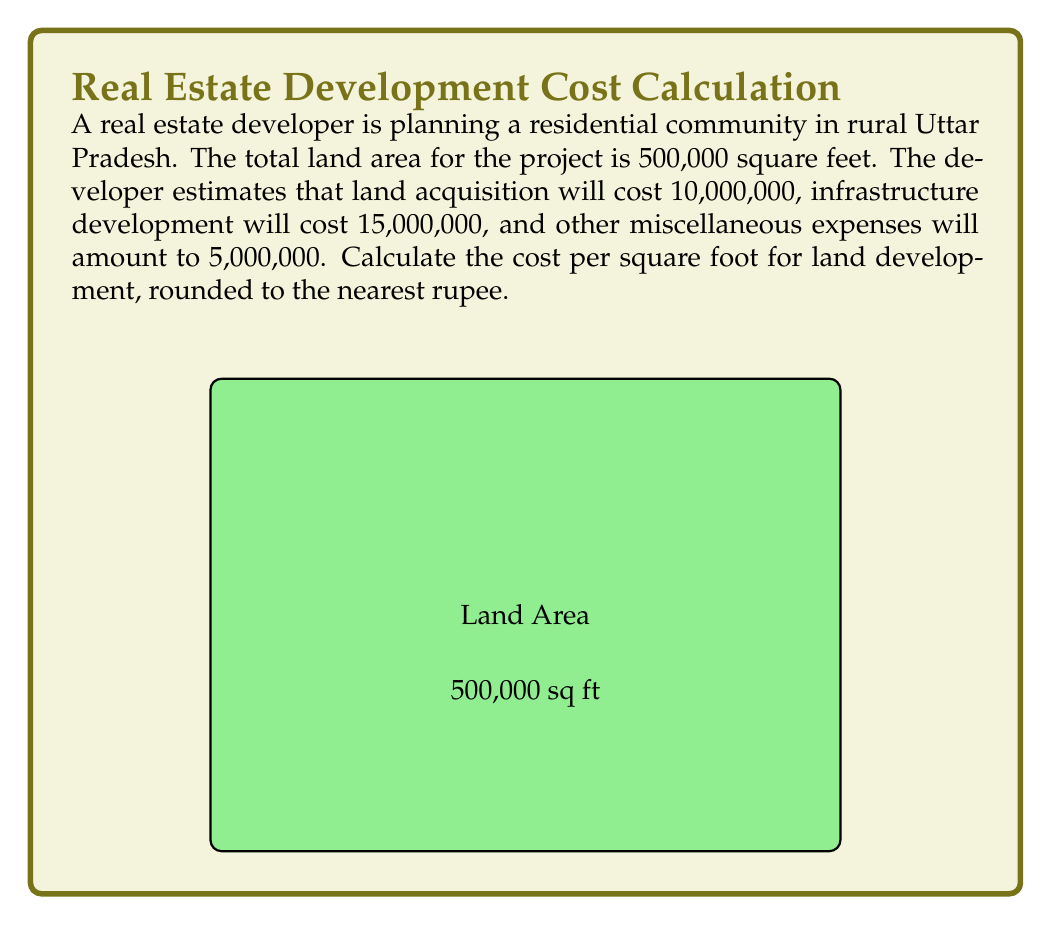Teach me how to tackle this problem. Let's approach this step-by-step:

1) First, we need to calculate the total cost of the project:
   Land acquisition cost: ₹10,000,000
   Infrastructure development cost: ₹15,000,000
   Miscellaneous expenses: ₹5,000,000

   Total cost = ₹10,000,000 + ₹15,000,000 + ₹5,000,000 = ₹30,000,000

2) Now, we have:
   Total cost = ₹30,000,000
   Total area = 500,000 square feet

3) To calculate the cost per square foot, we use the formula:
   $$ \text{Cost per square foot} = \frac{\text{Total cost}}{\text{Total area}} $$

4) Substituting our values:
   $$ \text{Cost per square foot} = \frac{₹30,000,000}{500,000 \text{ sq ft}} $$

5) Simplifying:
   $$ \text{Cost per square foot} = ₹60 \text{ per sq ft} $$

6) The question asks to round to the nearest rupee, but our result is already a whole number, so no rounding is necessary.
Answer: ₹60 per sq ft 